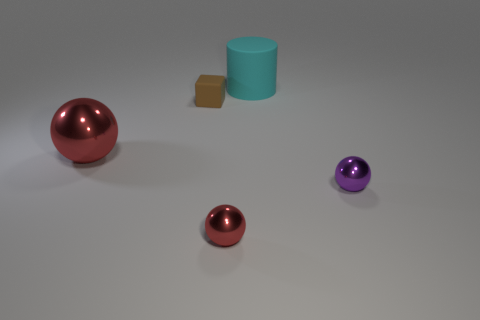Is there a large matte cylinder that has the same color as the big shiny sphere?
Make the answer very short. No. There is another shiny thing that is the same size as the cyan object; what color is it?
Give a very brief answer. Red. There is a metal thing to the right of the small red metal ball; is its color the same as the big cylinder?
Give a very brief answer. No. Are there any other big cylinders that have the same material as the cyan cylinder?
Your answer should be very brief. No. What is the shape of the metal object that is the same color as the big sphere?
Your answer should be very brief. Sphere. Is the number of small purple metallic things in front of the purple metal object less than the number of green metallic balls?
Your answer should be compact. No. Is the size of the red object that is on the left side of the brown matte object the same as the large cyan cylinder?
Offer a terse response. Yes. How many other red objects are the same shape as the big red thing?
Offer a terse response. 1. The object that is the same material as the tiny block is what size?
Your answer should be compact. Large. Are there the same number of small balls to the right of the rubber cylinder and cyan spheres?
Make the answer very short. No. 